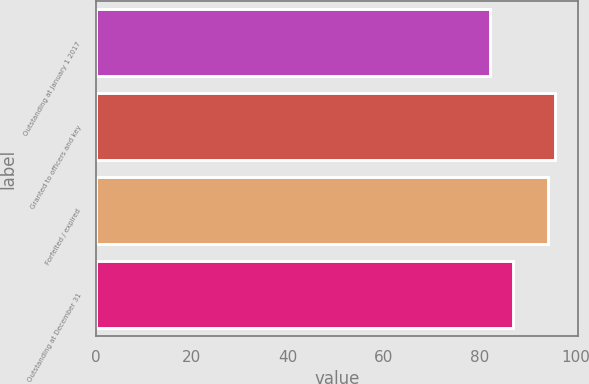Convert chart to OTSL. <chart><loc_0><loc_0><loc_500><loc_500><bar_chart><fcel>Outstanding at January 1 2017<fcel>Granted to officers and key<fcel>Forfeited / expired<fcel>Outstanding at December 31<nl><fcel>82.13<fcel>95.66<fcel>94.23<fcel>86.86<nl></chart> 